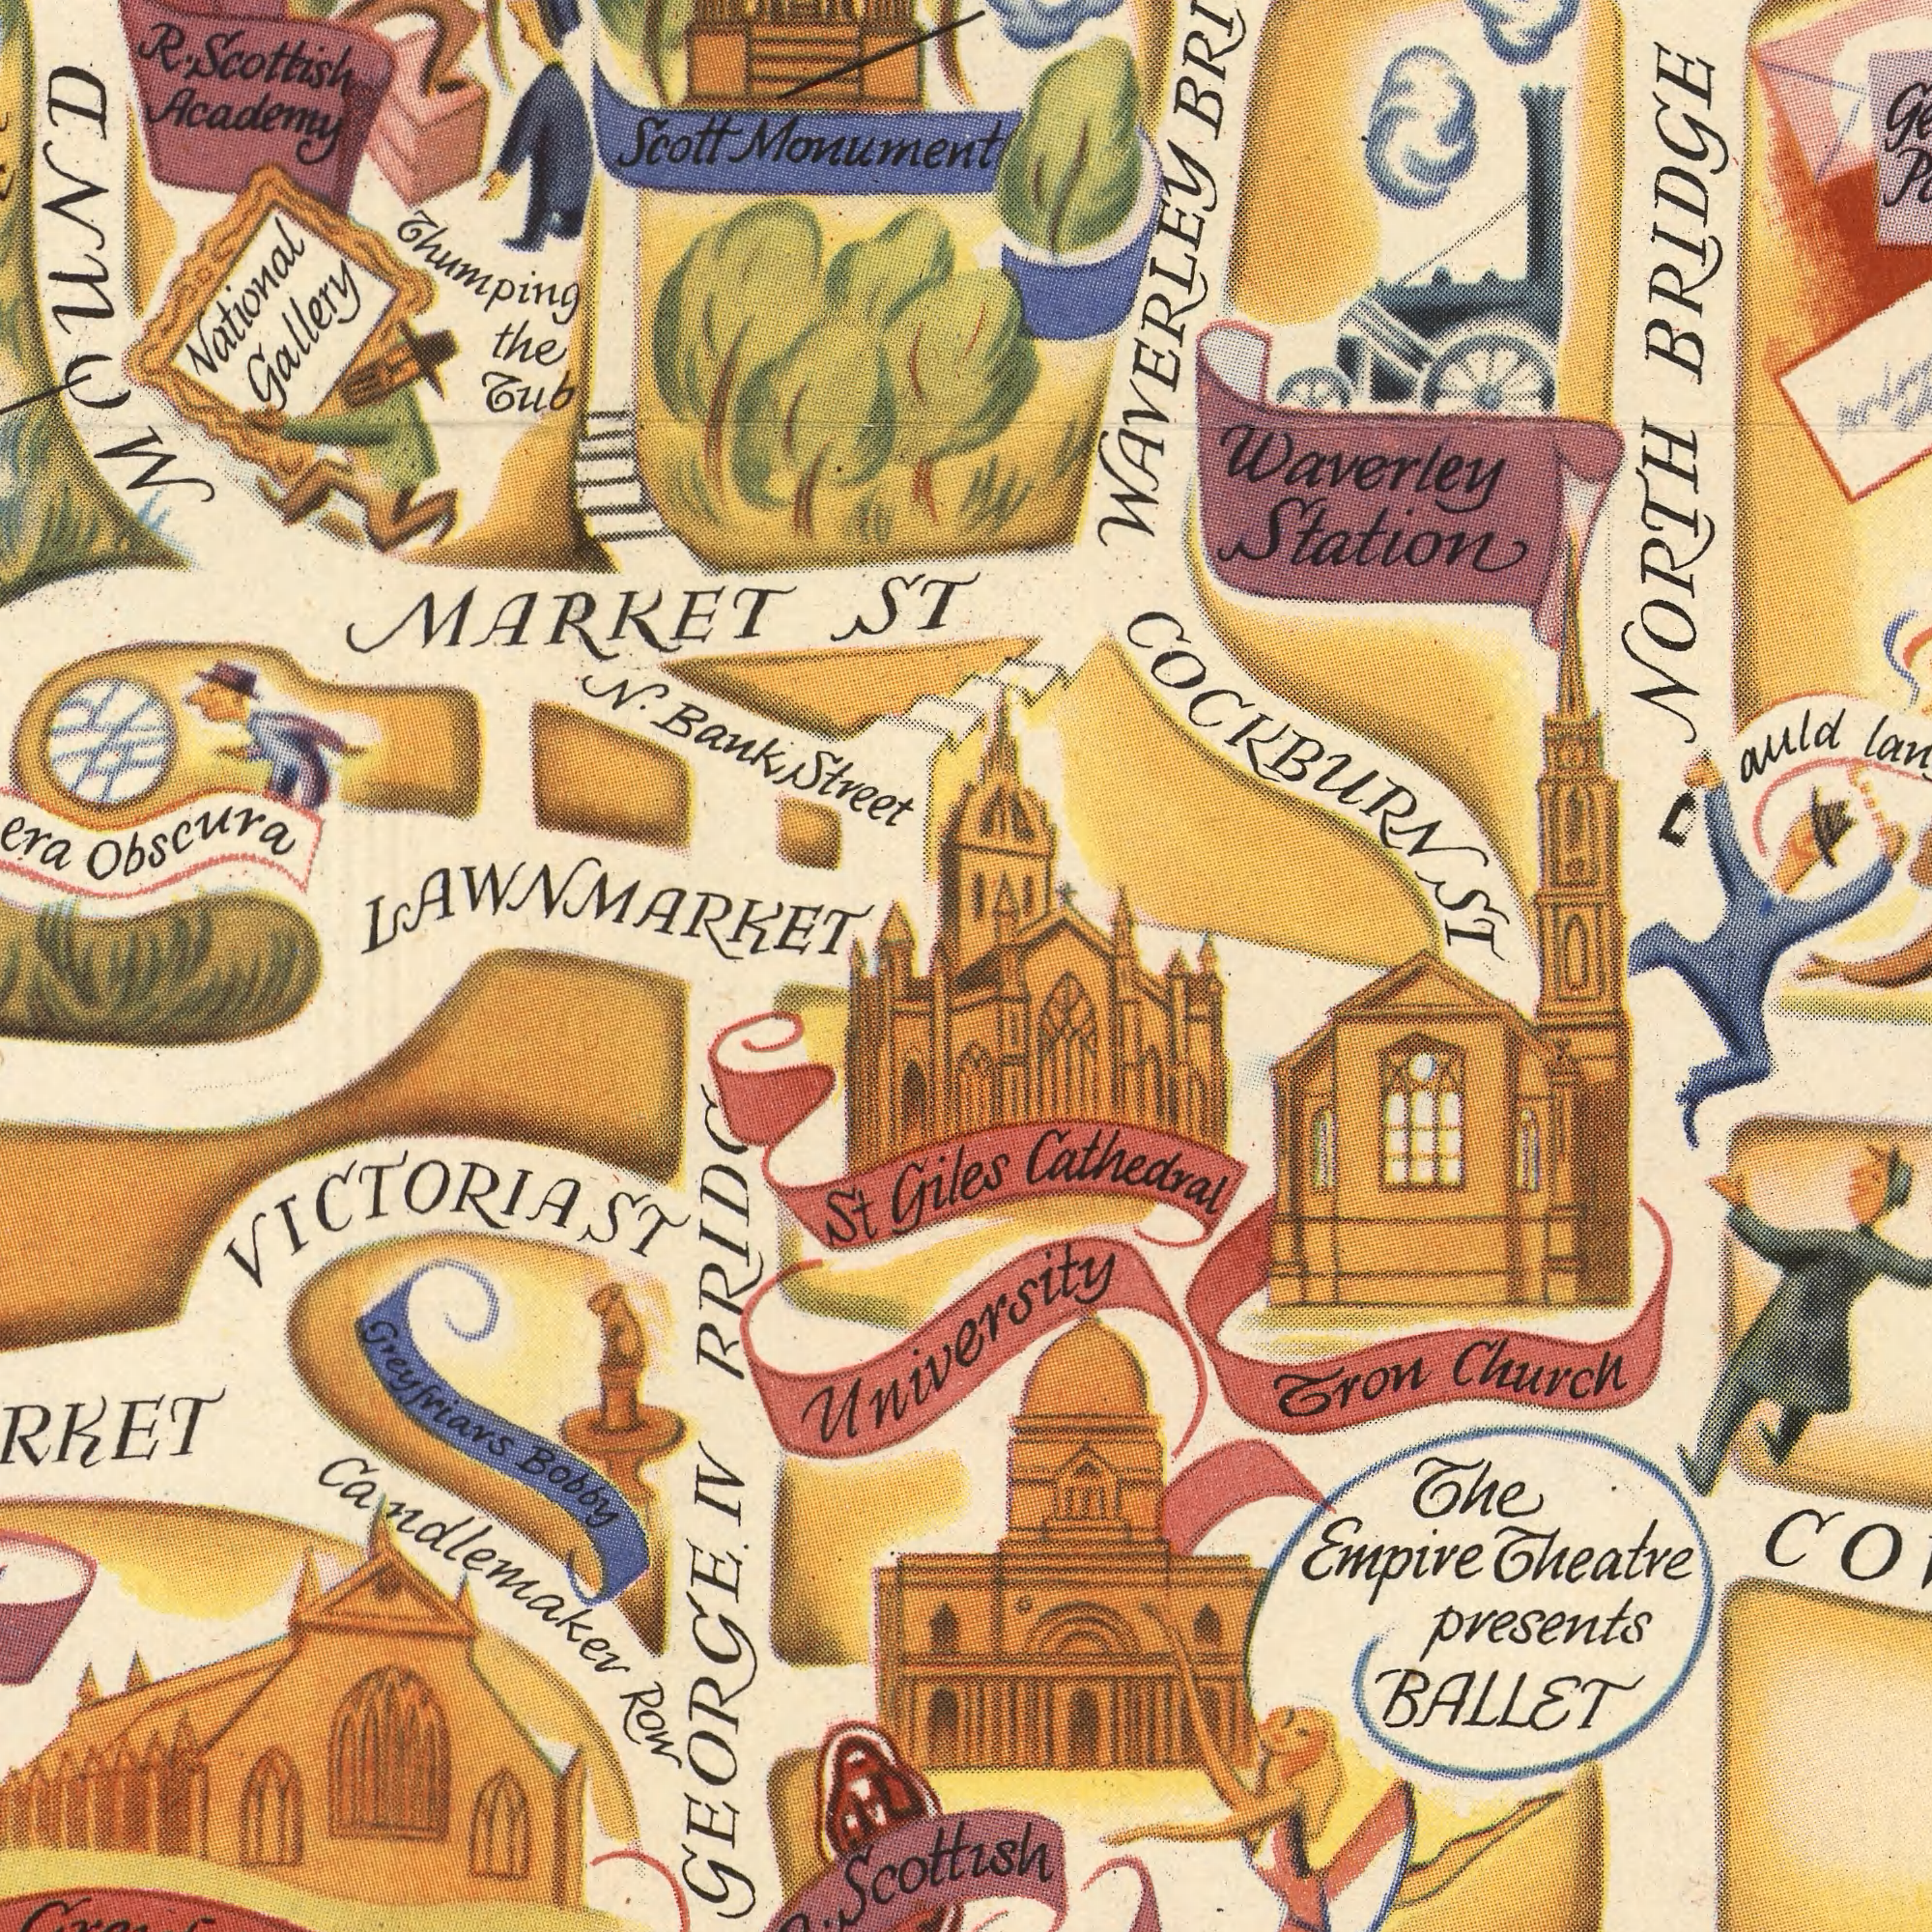What text is visible in the lower-right corner? Giles Church BALLET Cathedral Theatre Empire The Tron Presents university What text can you see in the bottom-left section? Bobby St Row Scottish Greyfriars Candlemaker GEORGE. VICTORIA ST IV What text can you see in the top-right section? waverley auld station BRIDGE NORTH WAVERLEY COCKBURN ST What text is shown in the top-left quadrant? National Scottish Monument Scott Academy Thumping Obscura N. Tup R. Street the Gallery ST MOUND MARKET Bank LAWNMARKET 